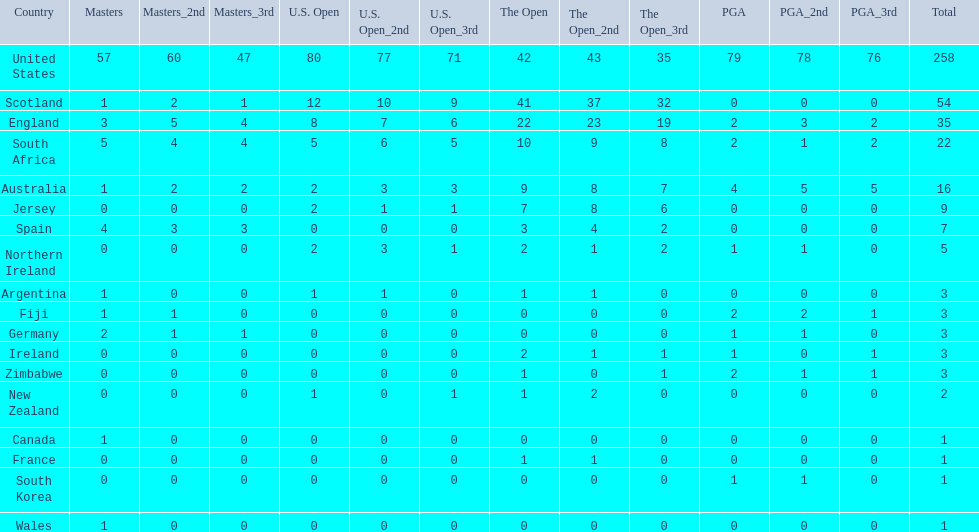Which of the countries listed are african? South Africa, Zimbabwe. Which of those has the least championship winning golfers? Zimbabwe. 